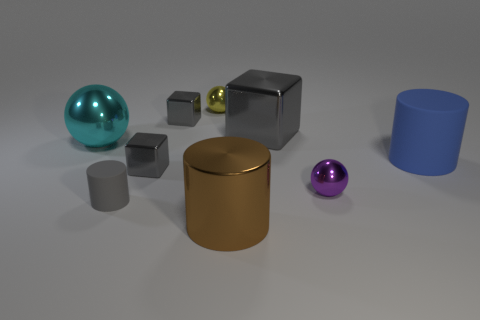Does the rubber object that is to the left of the blue object have the same color as the tiny metal sphere that is left of the big shiny cube?
Your response must be concise. No. There is a purple thing that is the same shape as the large cyan metal object; what size is it?
Your response must be concise. Small. Do the ball in front of the blue rubber thing and the big cylinder that is in front of the big blue rubber cylinder have the same material?
Offer a very short reply. Yes. What number of metal objects are tiny gray objects or blue cylinders?
Make the answer very short. 2. There is a cylinder that is behind the sphere that is on the right side of the big cylinder in front of the purple sphere; what is its material?
Offer a very short reply. Rubber. Is the shape of the matte object right of the brown cylinder the same as the large metallic object to the left of the gray cylinder?
Give a very brief answer. No. What is the color of the matte thing that is to the right of the purple thing that is behind the gray matte thing?
Your answer should be very brief. Blue. What number of cylinders are tiny gray objects or large gray objects?
Your response must be concise. 1. What number of tiny gray things are in front of the small gray metal block that is behind the big shiny thing on the left side of the brown thing?
Your answer should be compact. 2. The cylinder that is the same color as the large metal block is what size?
Offer a very short reply. Small. 